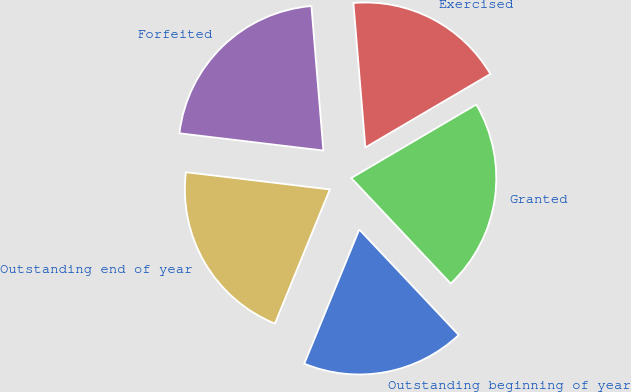Convert chart to OTSL. <chart><loc_0><loc_0><loc_500><loc_500><pie_chart><fcel>Outstanding beginning of year<fcel>Granted<fcel>Exercised<fcel>Forfeited<fcel>Outstanding end of year<nl><fcel>18.22%<fcel>21.43%<fcel>17.86%<fcel>21.79%<fcel>20.71%<nl></chart> 